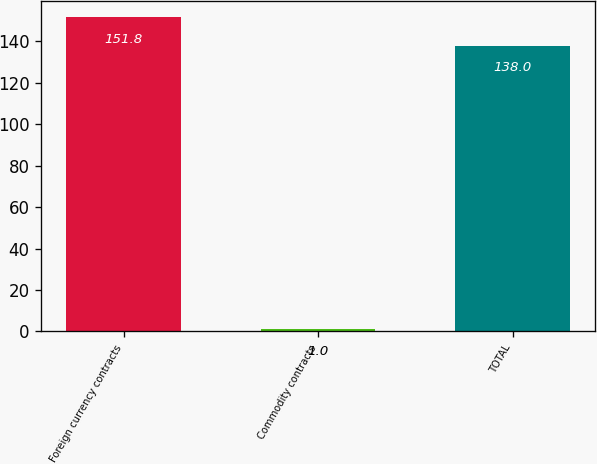<chart> <loc_0><loc_0><loc_500><loc_500><bar_chart><fcel>Foreign currency contracts<fcel>Commodity contracts<fcel>TOTAL<nl><fcel>151.8<fcel>1<fcel>138<nl></chart> 